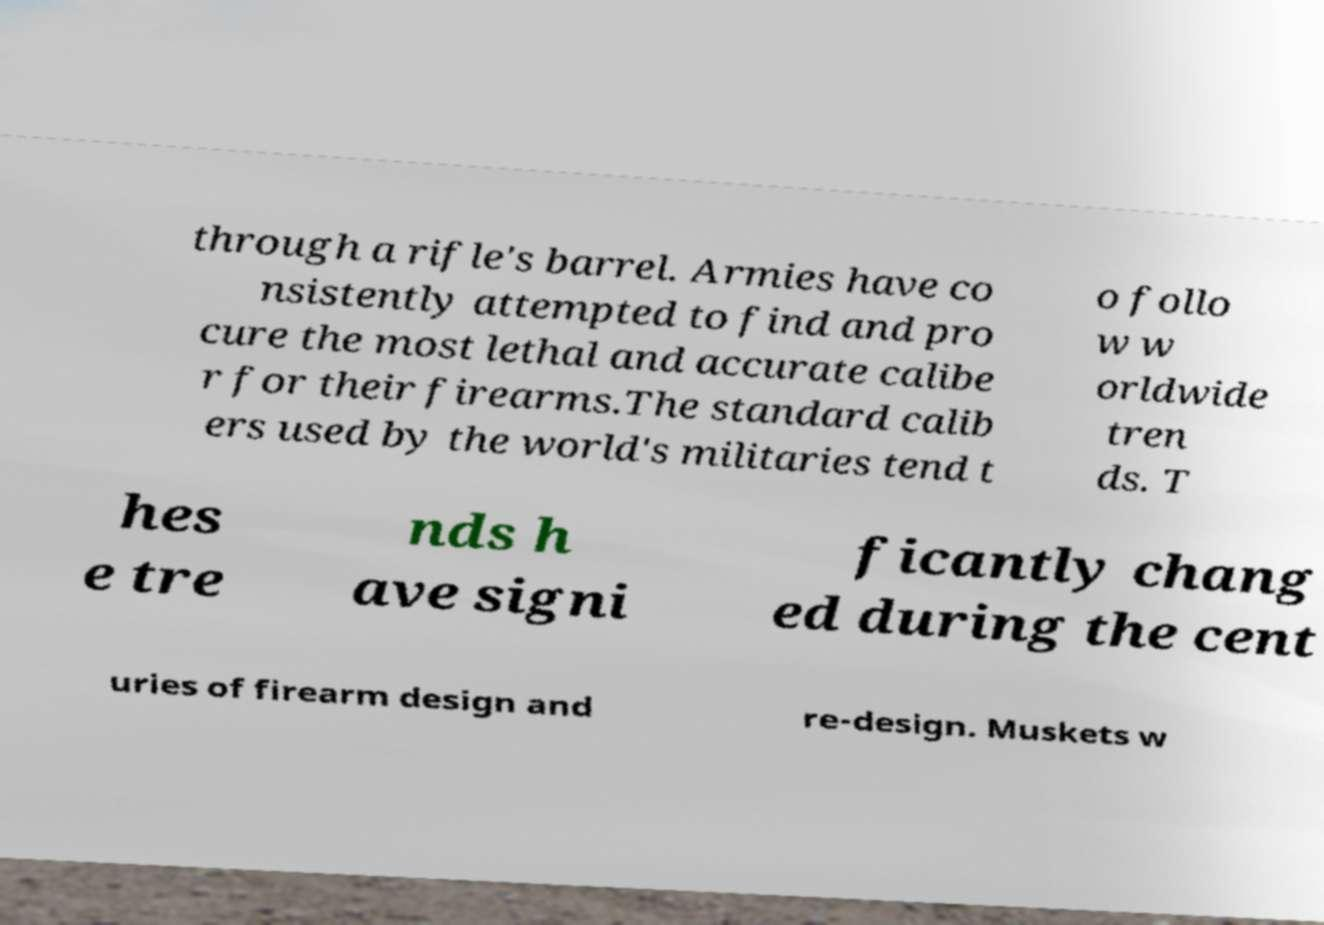Could you extract and type out the text from this image? through a rifle's barrel. Armies have co nsistently attempted to find and pro cure the most lethal and accurate calibe r for their firearms.The standard calib ers used by the world's militaries tend t o follo w w orldwide tren ds. T hes e tre nds h ave signi ficantly chang ed during the cent uries of firearm design and re-design. Muskets w 